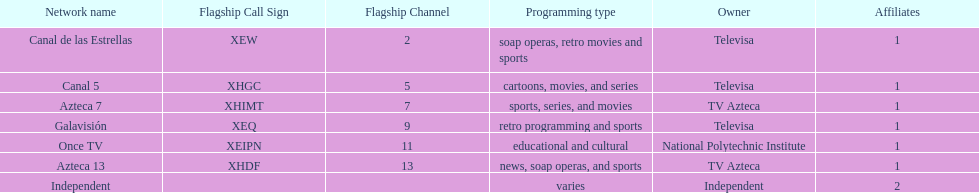What is the average number of affiliates that a given network will have? 1. 